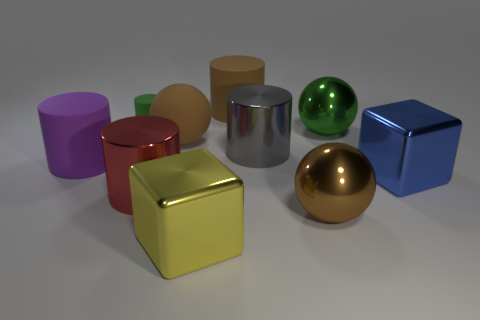Subtract all small cylinders. How many cylinders are left? 4 Subtract 1 cylinders. How many cylinders are left? 4 Subtract all brown spheres. How many spheres are left? 1 Subtract 1 yellow cubes. How many objects are left? 9 Subtract all spheres. How many objects are left? 7 Subtract all purple blocks. Subtract all yellow cylinders. How many blocks are left? 2 Subtract all yellow blocks. How many yellow balls are left? 0 Subtract all rubber cylinders. Subtract all big brown spheres. How many objects are left? 5 Add 2 large brown metallic spheres. How many large brown metallic spheres are left? 3 Add 1 large matte cylinders. How many large matte cylinders exist? 3 